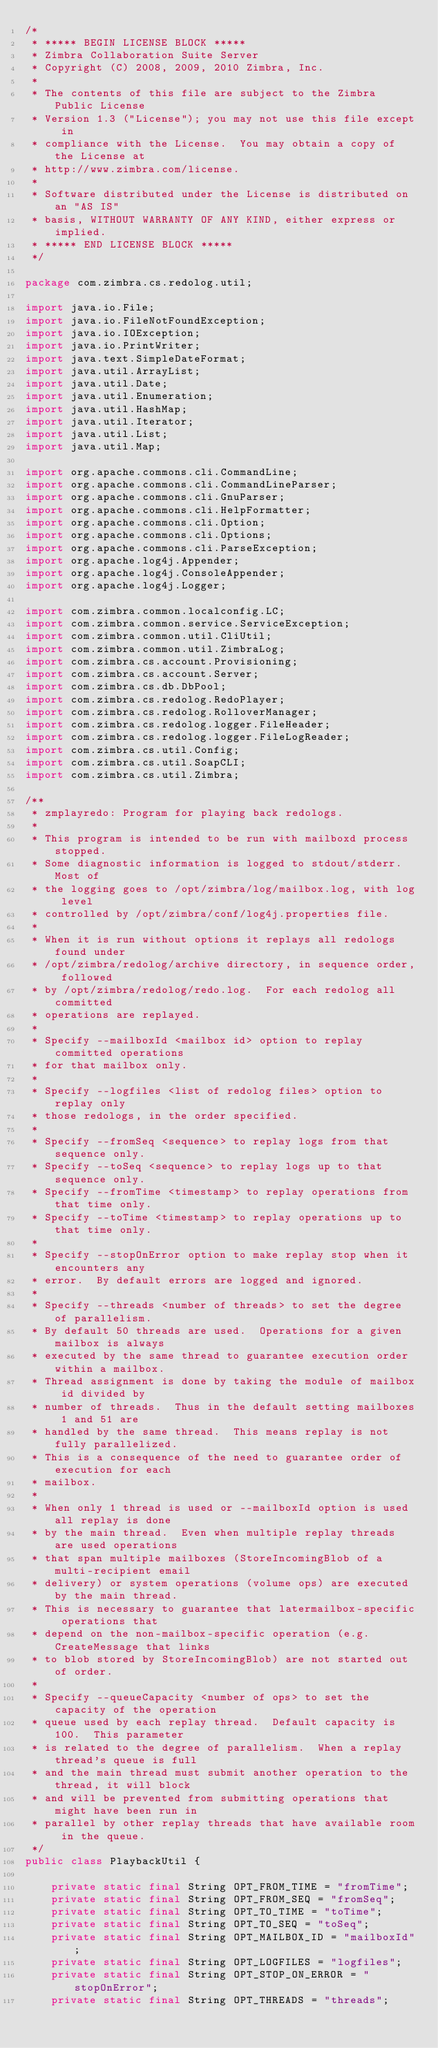Convert code to text. <code><loc_0><loc_0><loc_500><loc_500><_Java_>/*
 * ***** BEGIN LICENSE BLOCK *****
 * Zimbra Collaboration Suite Server
 * Copyright (C) 2008, 2009, 2010 Zimbra, Inc.
 *
 * The contents of this file are subject to the Zimbra Public License
 * Version 1.3 ("License"); you may not use this file except in
 * compliance with the License.  You may obtain a copy of the License at
 * http://www.zimbra.com/license.
 *
 * Software distributed under the License is distributed on an "AS IS"
 * basis, WITHOUT WARRANTY OF ANY KIND, either express or implied.
 * ***** END LICENSE BLOCK *****
 */

package com.zimbra.cs.redolog.util;

import java.io.File;
import java.io.FileNotFoundException;
import java.io.IOException;
import java.io.PrintWriter;
import java.text.SimpleDateFormat;
import java.util.ArrayList;
import java.util.Date;
import java.util.Enumeration;
import java.util.HashMap;
import java.util.Iterator;
import java.util.List;
import java.util.Map;

import org.apache.commons.cli.CommandLine;
import org.apache.commons.cli.CommandLineParser;
import org.apache.commons.cli.GnuParser;
import org.apache.commons.cli.HelpFormatter;
import org.apache.commons.cli.Option;
import org.apache.commons.cli.Options;
import org.apache.commons.cli.ParseException;
import org.apache.log4j.Appender;
import org.apache.log4j.ConsoleAppender;
import org.apache.log4j.Logger;

import com.zimbra.common.localconfig.LC;
import com.zimbra.common.service.ServiceException;
import com.zimbra.common.util.CliUtil;
import com.zimbra.common.util.ZimbraLog;
import com.zimbra.cs.account.Provisioning;
import com.zimbra.cs.account.Server;
import com.zimbra.cs.db.DbPool;
import com.zimbra.cs.redolog.RedoPlayer;
import com.zimbra.cs.redolog.RolloverManager;
import com.zimbra.cs.redolog.logger.FileHeader;
import com.zimbra.cs.redolog.logger.FileLogReader;
import com.zimbra.cs.util.Config;
import com.zimbra.cs.util.SoapCLI;
import com.zimbra.cs.util.Zimbra;

/**
 * zmplayredo: Program for playing back redologs.
 *
 * This program is intended to be run with mailboxd process stopped.
 * Some diagnostic information is logged to stdout/stderr.  Most of
 * the logging goes to /opt/zimbra/log/mailbox.log, with log level
 * controlled by /opt/zimbra/conf/log4j.properties file.
 *
 * When it is run without options it replays all redologs found under
 * /opt/zimbra/redolog/archive directory, in sequence order, followed
 * by /opt/zimbra/redolog/redo.log.  For each redolog all committed
 * operations are replayed.
 *
 * Specify --mailboxId <mailbox id> option to replay committed operations
 * for that mailbox only.
 *
 * Specify --logfiles <list of redolog files> option to replay only
 * those redologs, in the order specified.
 *
 * Specify --fromSeq <sequence> to replay logs from that sequence only.
 * Specify --toSeq <sequence> to replay logs up to that sequence only.
 * Specify --fromTime <timestamp> to replay operations from that time only.
 * Specify --toTime <timestamp> to replay operations up to that time only.
 *
 * Specify --stopOnError option to make replay stop when it encounters any
 * error.  By default errors are logged and ignored.
 *
 * Specify --threads <number of threads> to set the degree of parallelism.
 * By default 50 threads are used.  Operations for a given mailbox is always
 * executed by the same thread to guarantee execution order within a mailbox.
 * Thread assignment is done by taking the module of mailbox id divided by
 * number of threads.  Thus in the default setting mailboxes 1 and 51 are
 * handled by the same thread.  This means replay is not fully parallelized.
 * This is a consequence of the need to guarantee order of execution for each
 * mailbox.
 *
 * When only 1 thread is used or --mailboxId option is used all replay is done
 * by the main thread.  Even when multiple replay threads are used operations
 * that span multiple mailboxes (StoreIncomingBlob of a multi-recipient email
 * delivery) or system operations (volume ops) are executed by the main thread.
 * This is necessary to guarantee that latermailbox-specific operations that
 * depend on the non-mailbox-specific operation (e.g. CreateMessage that links
 * to blob stored by StoreIncomingBlob) are not started out of order.
 *
 * Specify --queueCapacity <number of ops> to set the capacity of the operation
 * queue used by each replay thread.  Default capacity is 100.  This parameter
 * is related to the degree of parallelism.  When a replay thread's queue is full
 * and the main thread must submit another operation to the thread, it will block
 * and will be prevented from submitting operations that might have been run in
 * parallel by other replay threads that have available room in the queue.
 */
public class PlaybackUtil {

    private static final String OPT_FROM_TIME = "fromTime";
    private static final String OPT_FROM_SEQ = "fromSeq";
    private static final String OPT_TO_TIME = "toTime";
    private static final String OPT_TO_SEQ = "toSeq";
    private static final String OPT_MAILBOX_ID = "mailboxId";
    private static final String OPT_LOGFILES = "logfiles";
    private static final String OPT_STOP_ON_ERROR = "stopOnError";
    private static final String OPT_THREADS = "threads";</code> 